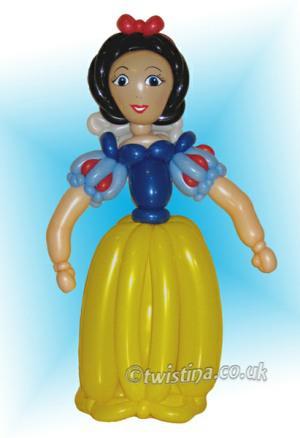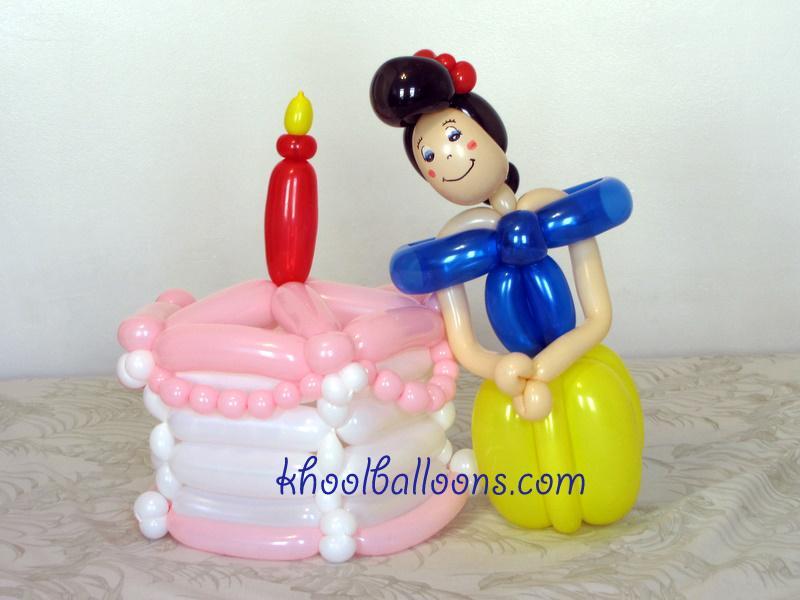The first image is the image on the left, the second image is the image on the right. Assess this claim about the two images: "There are two princess balloon figures looking forward.". Correct or not? Answer yes or no. Yes. 